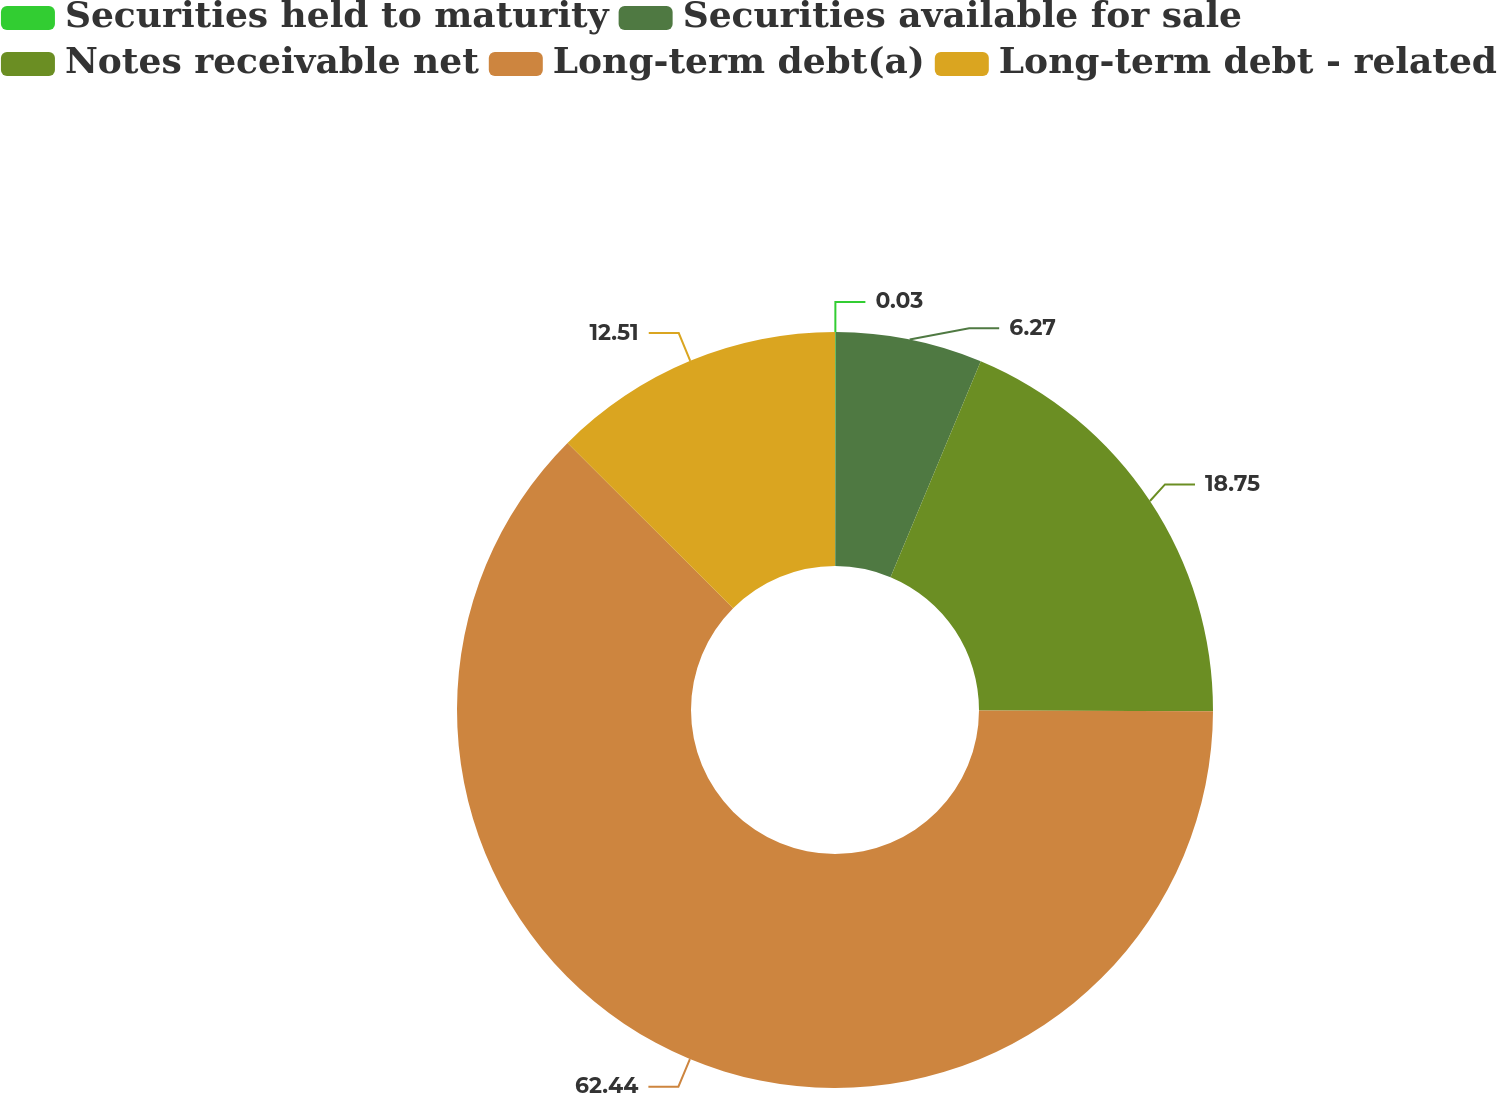Convert chart. <chart><loc_0><loc_0><loc_500><loc_500><pie_chart><fcel>Securities held to maturity<fcel>Securities available for sale<fcel>Notes receivable net<fcel>Long-term debt(a)<fcel>Long-term debt - related<nl><fcel>0.03%<fcel>6.27%<fcel>18.75%<fcel>62.44%<fcel>12.51%<nl></chart> 